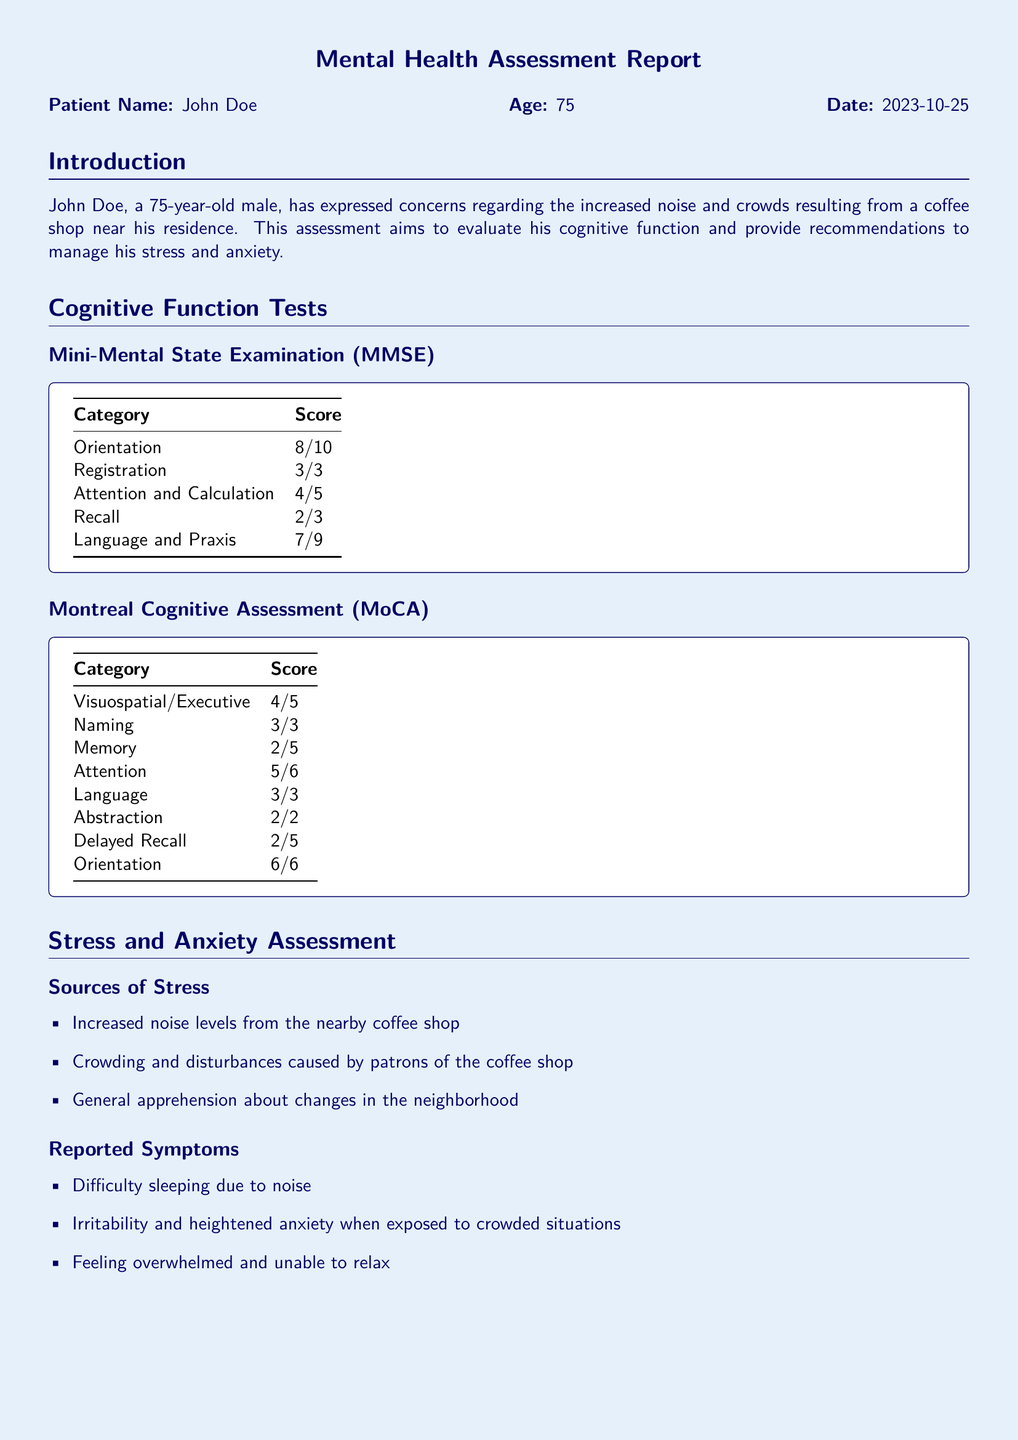What is the patient's name? The patient's name is provided in the document as part of the introductory information.
Answer: John Doe What is the patient's age? The age of the patient is listed next to the name in the introduction section.
Answer: 75 When was the assessment conducted? The date of the assessment is mentioned in the introductory section.
Answer: 2023-10-25 What is the score for Orientation in the MMSE? The score for Orientation is specified in the cognitive function tests section under MMSE.
Answer: 8/10 What are the reported symptoms of the patient? The symptoms reported by the patient are listed under the Stress and Anxiety Assessment section.
Answer: Difficulty sleeping, irritability, feeling overwhelmed Which cognitive test assesses memory using a different method? The document includes two cognitive function tests and the MoCA assesses memory separately.
Answer: MoCA What is one recommended lifestyle change? Recommendations for managing stress include various categories, and one pertains to lifestyle adjustments.
Answer: Regular physical activities What cognitive engagement is suggested in the recommendations? The recommendations section includes suggestions for cognitive activities to keep the mind engaged.
Answer: Engage in mentally stimulating activities 